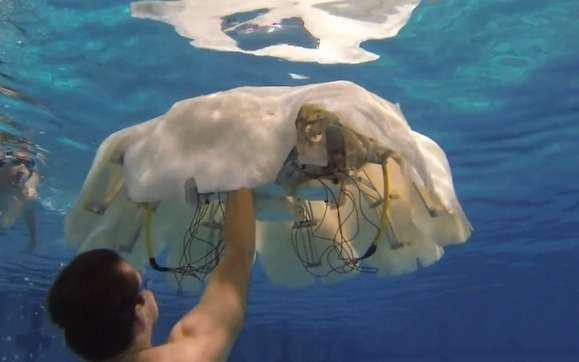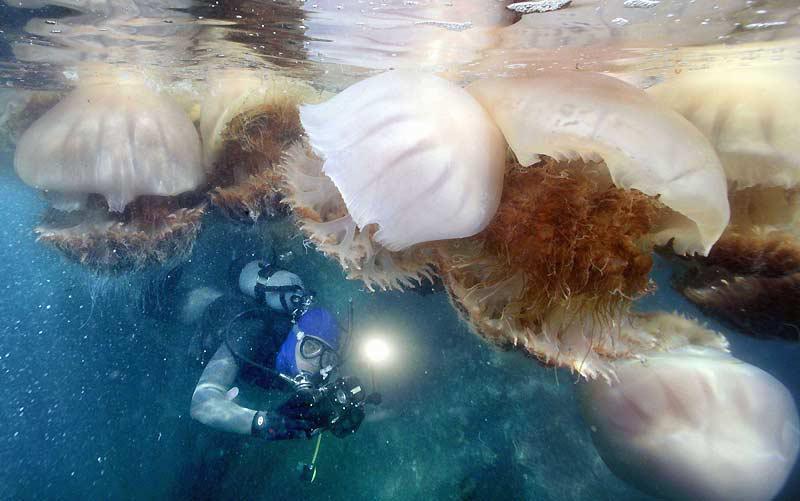The first image is the image on the left, the second image is the image on the right. Analyze the images presented: Is the assertion "There is at least one person without an airtank." valid? Answer yes or no. Yes. 